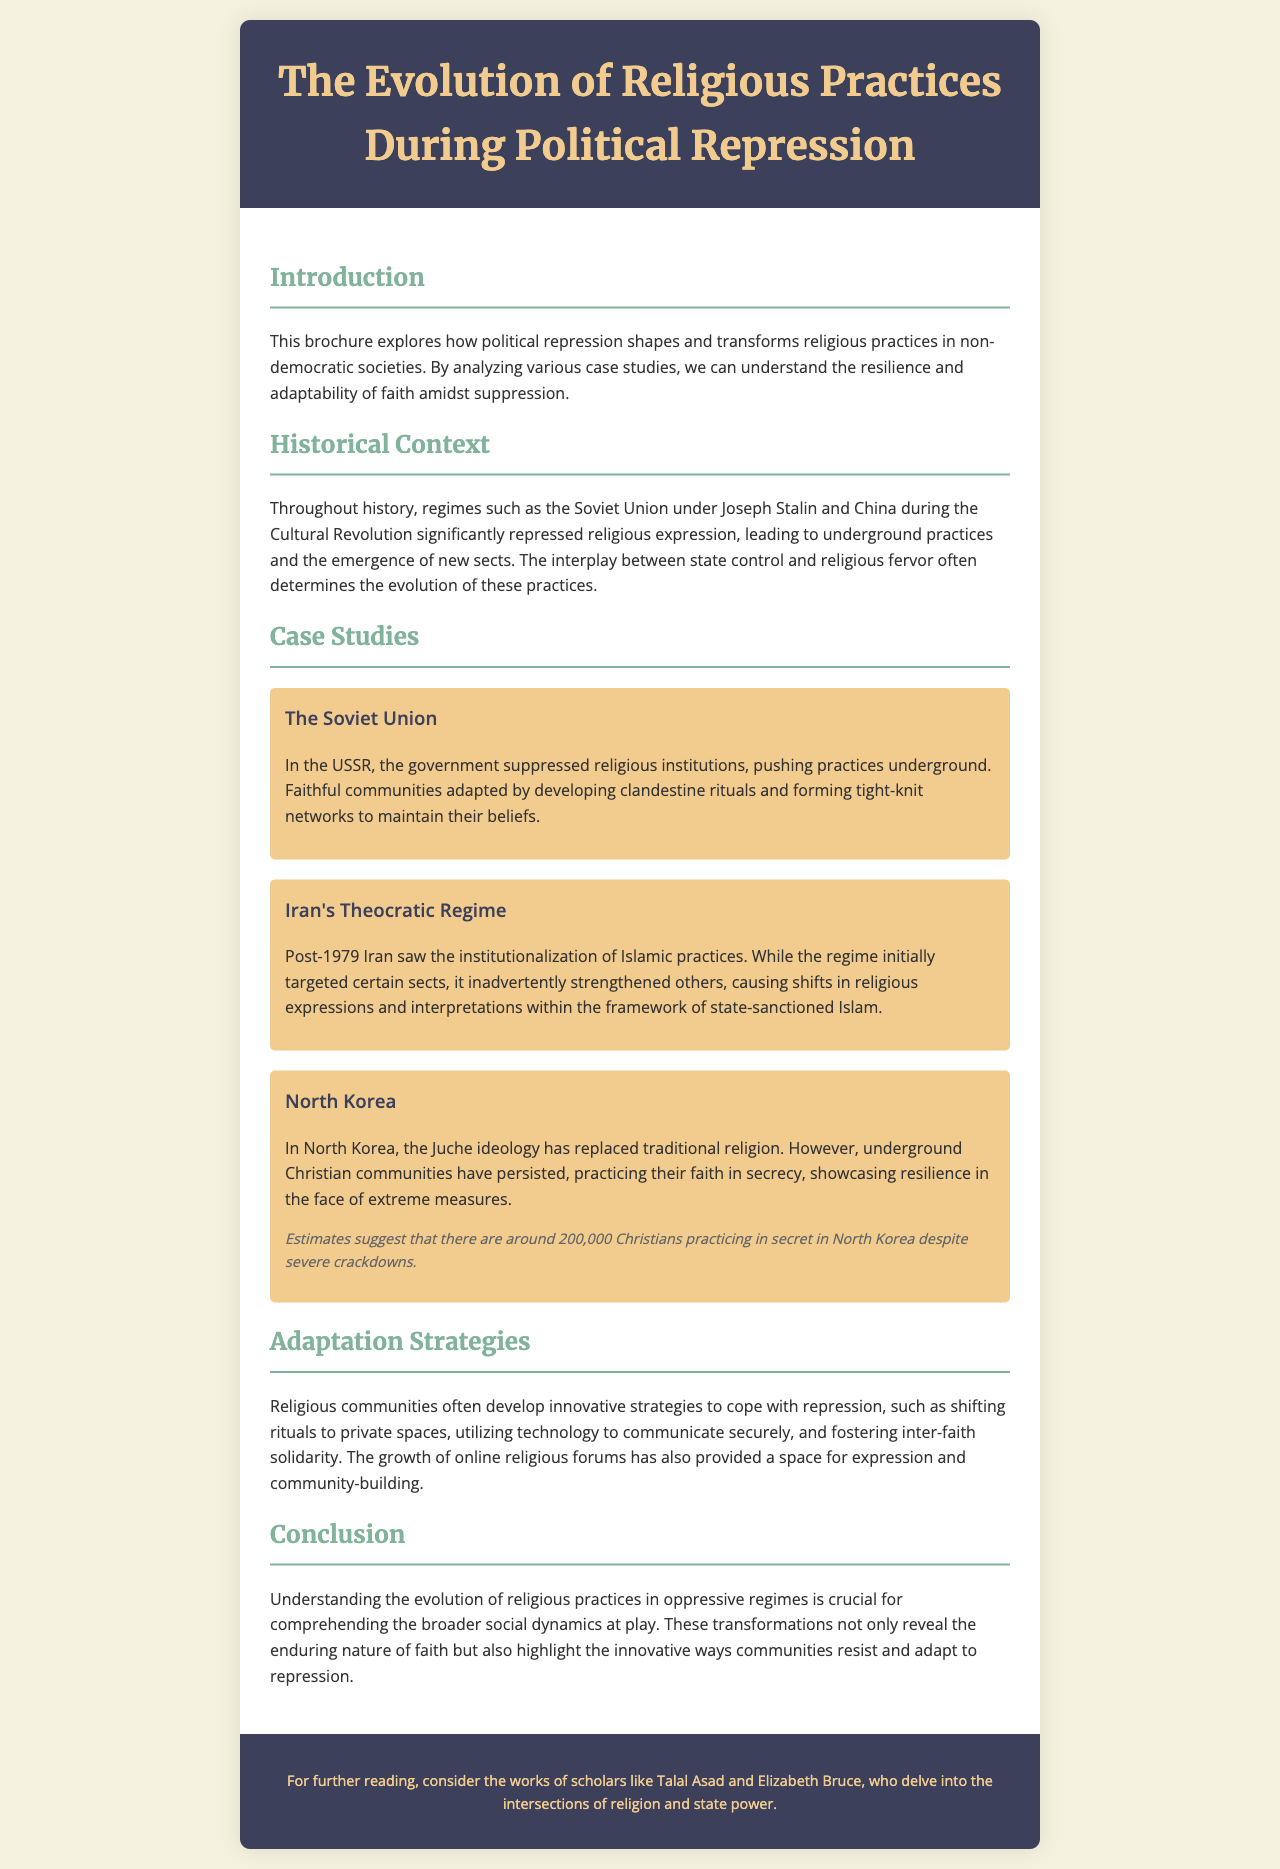What is the main topic of the brochure? The brochure discusses how political repression shapes and transforms religious practices in non-democratic societies.
Answer: The Evolution of Religious Practices During Political Repression Which country’s religious practices involved clandestine rituals? The document mentions the government suppressed religious institutions in this country, leading to underground practices.
Answer: The Soviet Union What significant event took place in Iran in 1979? The text indicates this event marked a major change in religious practices under a theocratic regime.
Answer: The Islamic Revolution How many Christians are estimated to be practicing in secret in North Korea? The document provides a specific estimate of the number of underground Christians in North Korea despite crackdowns.
Answer: 200,000 What adaptation strategy do religious communities use to cope with repression? The brochure lists various strategies, including one that involves utilizing technology for secure communication.
Answer: Using technology to communicate securely What did the Iranian regime's initial actions target? The document states that the regime focused its repression on certain groups but also caused shifts in other religious expressions.
Answer: Certain sects Who are the scholars mentioned for further reading? The document suggests names of scholars who explore the intersections of religion and state power.
Answer: Talal Asad and Elizabeth Bruce What type of document is this? The format and content suggest a specific purpose, typical of documents aimed at education and awareness.
Answer: Brochure 